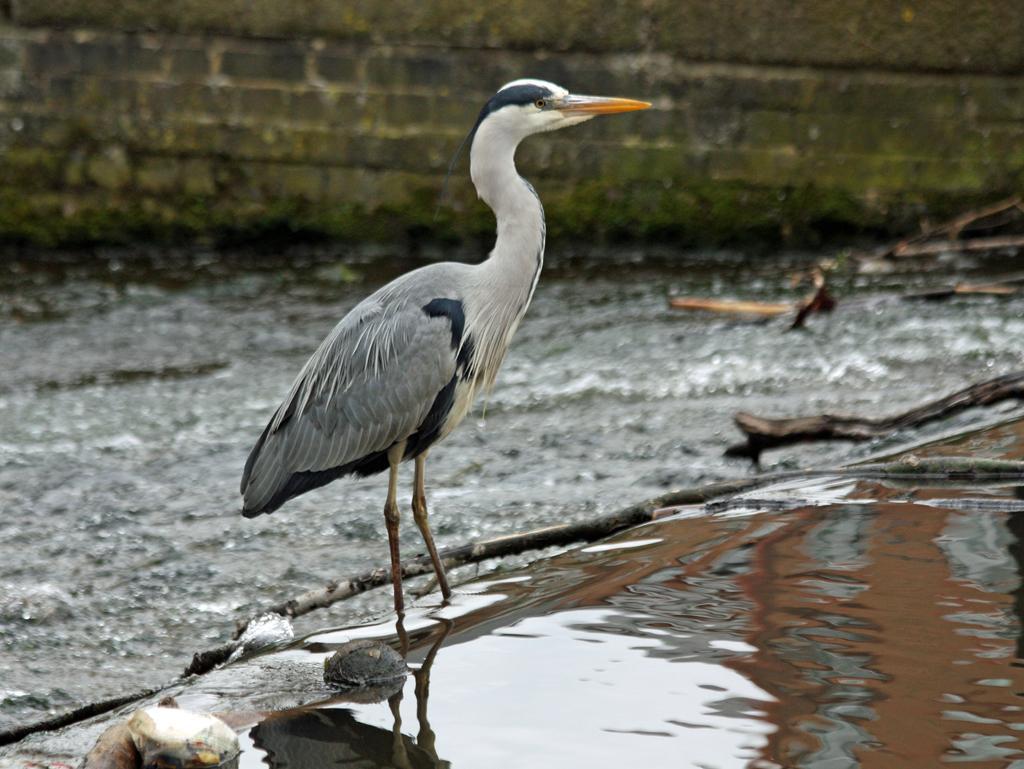How would you summarize this image in a sentence or two? In this image we can see a bird is standing here. Here we can see the water and the background of the image is slightly blurred, where we can see the ground and the stone wall. 